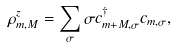Convert formula to latex. <formula><loc_0><loc_0><loc_500><loc_500>\rho ^ { z } _ { m , M } = \sum _ { \sigma } \sigma c ^ { \dagger } _ { m + M , \sigma } c _ { m , \sigma } ,</formula> 